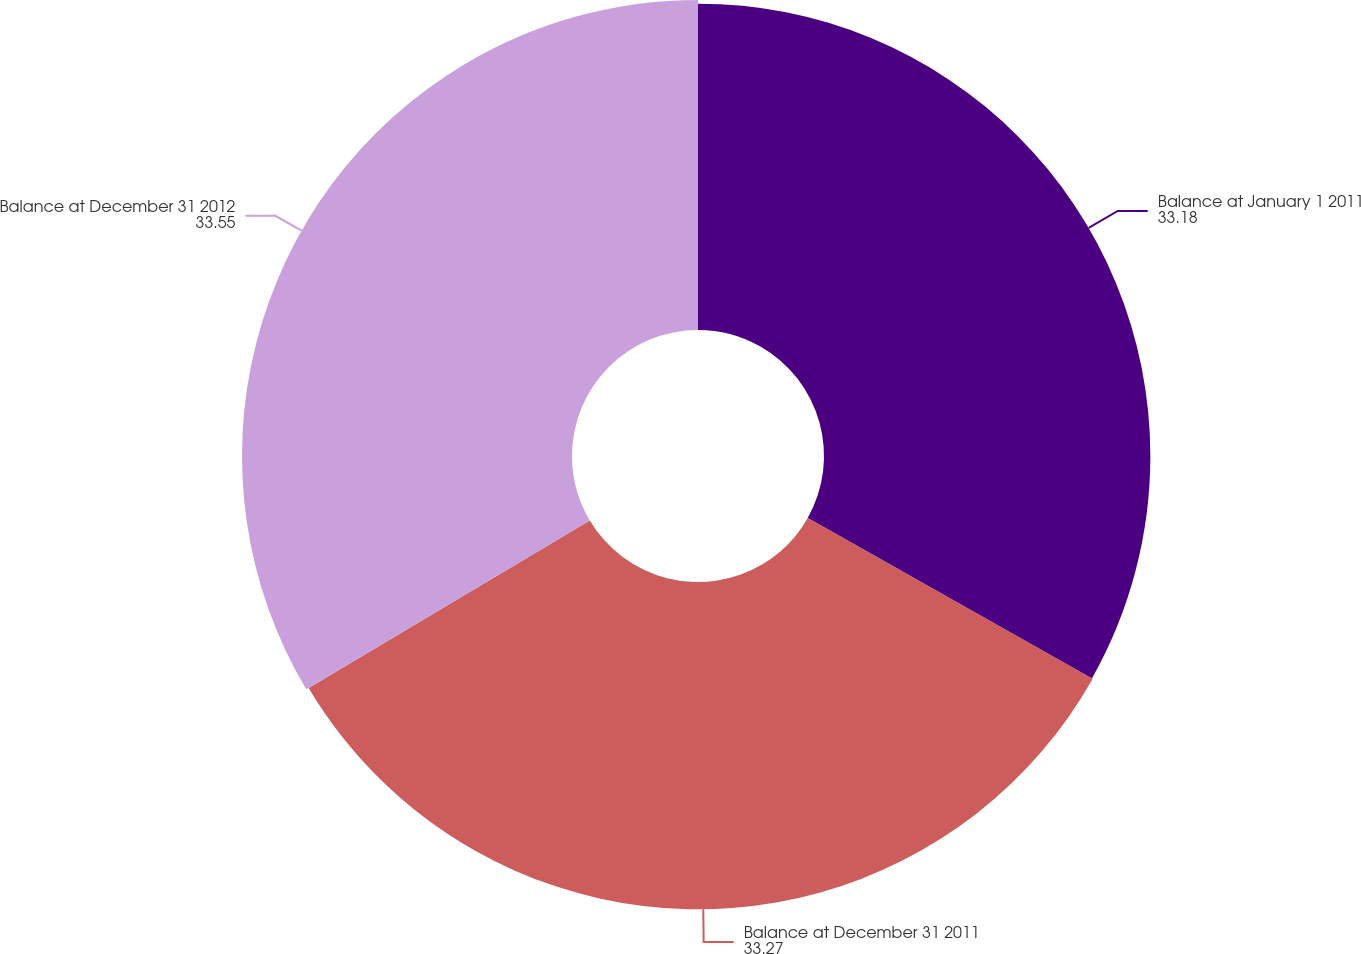<chart> <loc_0><loc_0><loc_500><loc_500><pie_chart><fcel>Balance at January 1 2011<fcel>Balance at December 31 2011<fcel>Balance at December 31 2012<nl><fcel>33.18%<fcel>33.27%<fcel>33.55%<nl></chart> 